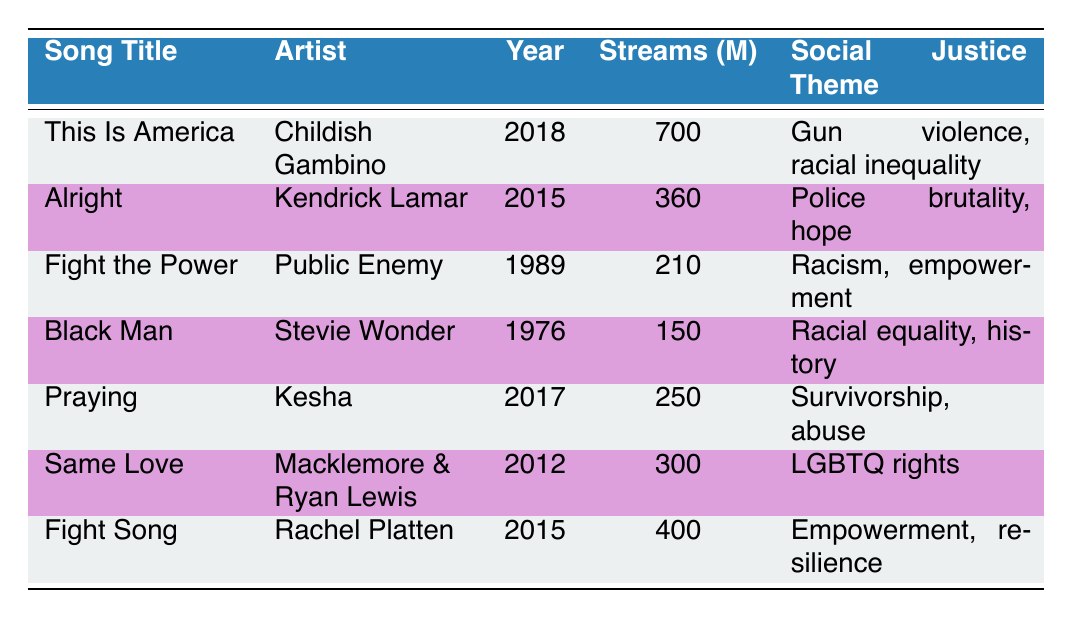What is the total number of streams for "This Is America" and "Alright"? The stream counts for "This Is America" and "Alright" are 700 million and 360 million respectively. Adding these gives a total of 700 + 360 = 1060 million streams.
Answer: 1060 million Which song has the highest number of streams? "This Is America" has the highest number of streams with 700 million, as it is the highest value listed in the Streams column.
Answer: "This Is America" Is the theme of "Fight Song" related to empowerment? Yes, the theme listed for "Fight Song" is indeed empowerment and resilience, indicating that it aligns with concepts of empowerment.
Answer: Yes What is the average number of streams for the listed songs? The streams of all songs listed are 700, 360, 210, 150, 250, 300, and 400 millions. The total streams combined is 700 + 360 + 210 + 150 + 250 + 300 + 400 = 2370 million. Dividing this by the 7 songs gives 2370 / 7 = 337.14 million.
Answer: 337.14 million Which artist has a song about police brutality? The artist Kendrick Lamar has a song titled "Alright" which addresses the theme of police brutality as mentioned in the table.
Answer: Kendrick Lamar How many songs focused on racial equality have more than 200 million streams? The songs focusing on racial equality are "This Is America," "Black Man," and "Alright." "This Is America" has 700 million, "Alright" has 360 million, and "Fight the Power," related to racism, has 210 million. All 3 songs exceed 200 million streams.
Answer: 3 